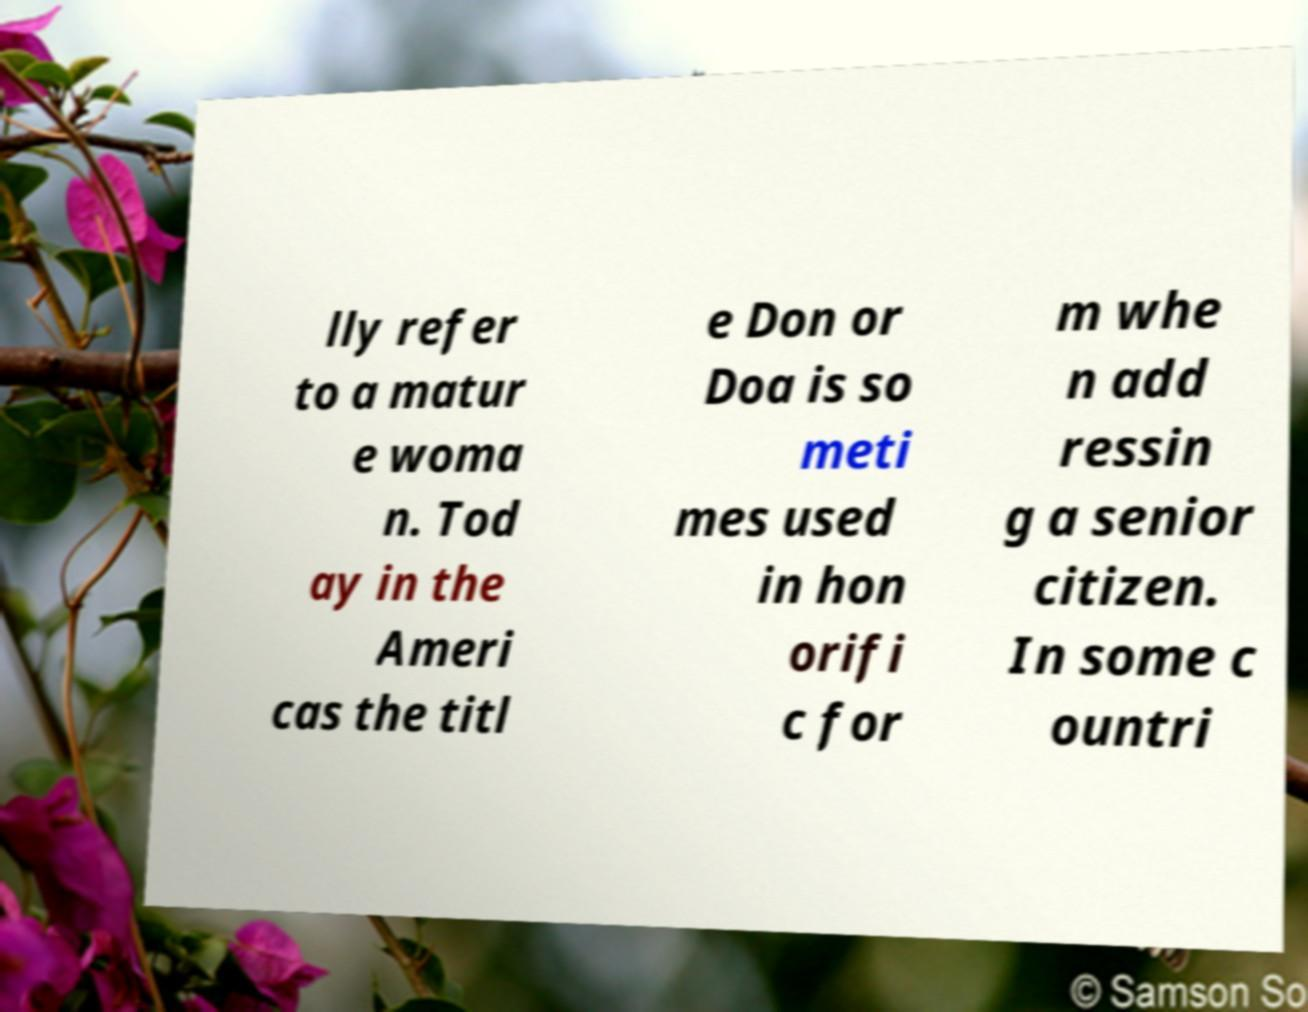Can you read and provide the text displayed in the image?This photo seems to have some interesting text. Can you extract and type it out for me? lly refer to a matur e woma n. Tod ay in the Ameri cas the titl e Don or Doa is so meti mes used in hon orifi c for m whe n add ressin g a senior citizen. In some c ountri 